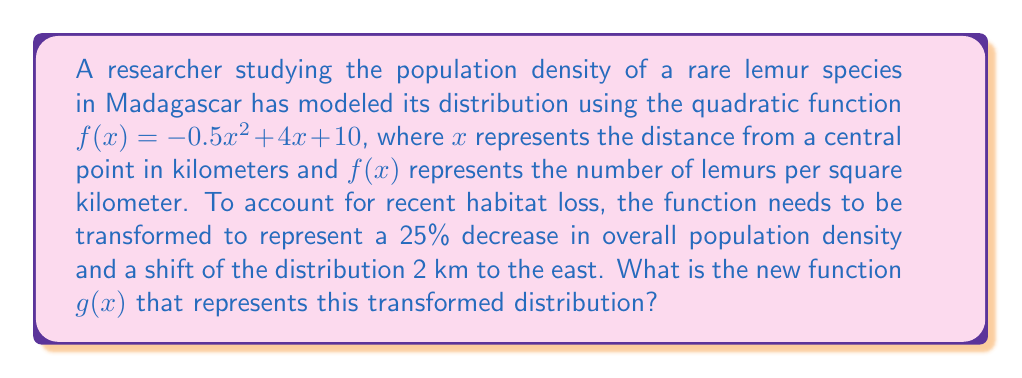Can you solve this math problem? To transform the original function $f(x) = -0.5x^2 + 4x + 10$, we need to apply two transformations:

1. Scale the function vertically by 0.75 to represent a 25% decrease in population density:
   $h(x) = 0.75f(x) = 0.75(-0.5x^2 + 4x + 10) = -0.375x^2 + 3x + 7.5$

2. Shift the function 2 units to the left (which represents 2 km to the east):
   Replace $x$ with $(x - 2)$ in $h(x)$:
   $g(x) = -0.375(x-2)^2 + 3(x-2) + 7.5$

Now, let's expand this expression:
$g(x) = -0.375(x^2 - 4x + 4) + 3x - 6 + 7.5$
$g(x) = -0.375x^2 + 1.5x - 1.5 + 3x - 6 + 7.5$
$g(x) = -0.375x^2 + 4.5x + 0$

Therefore, the new function representing the transformed distribution is $g(x) = -0.375x^2 + 4.5x$.
Answer: $g(x) = -0.375x^2 + 4.5x$ 